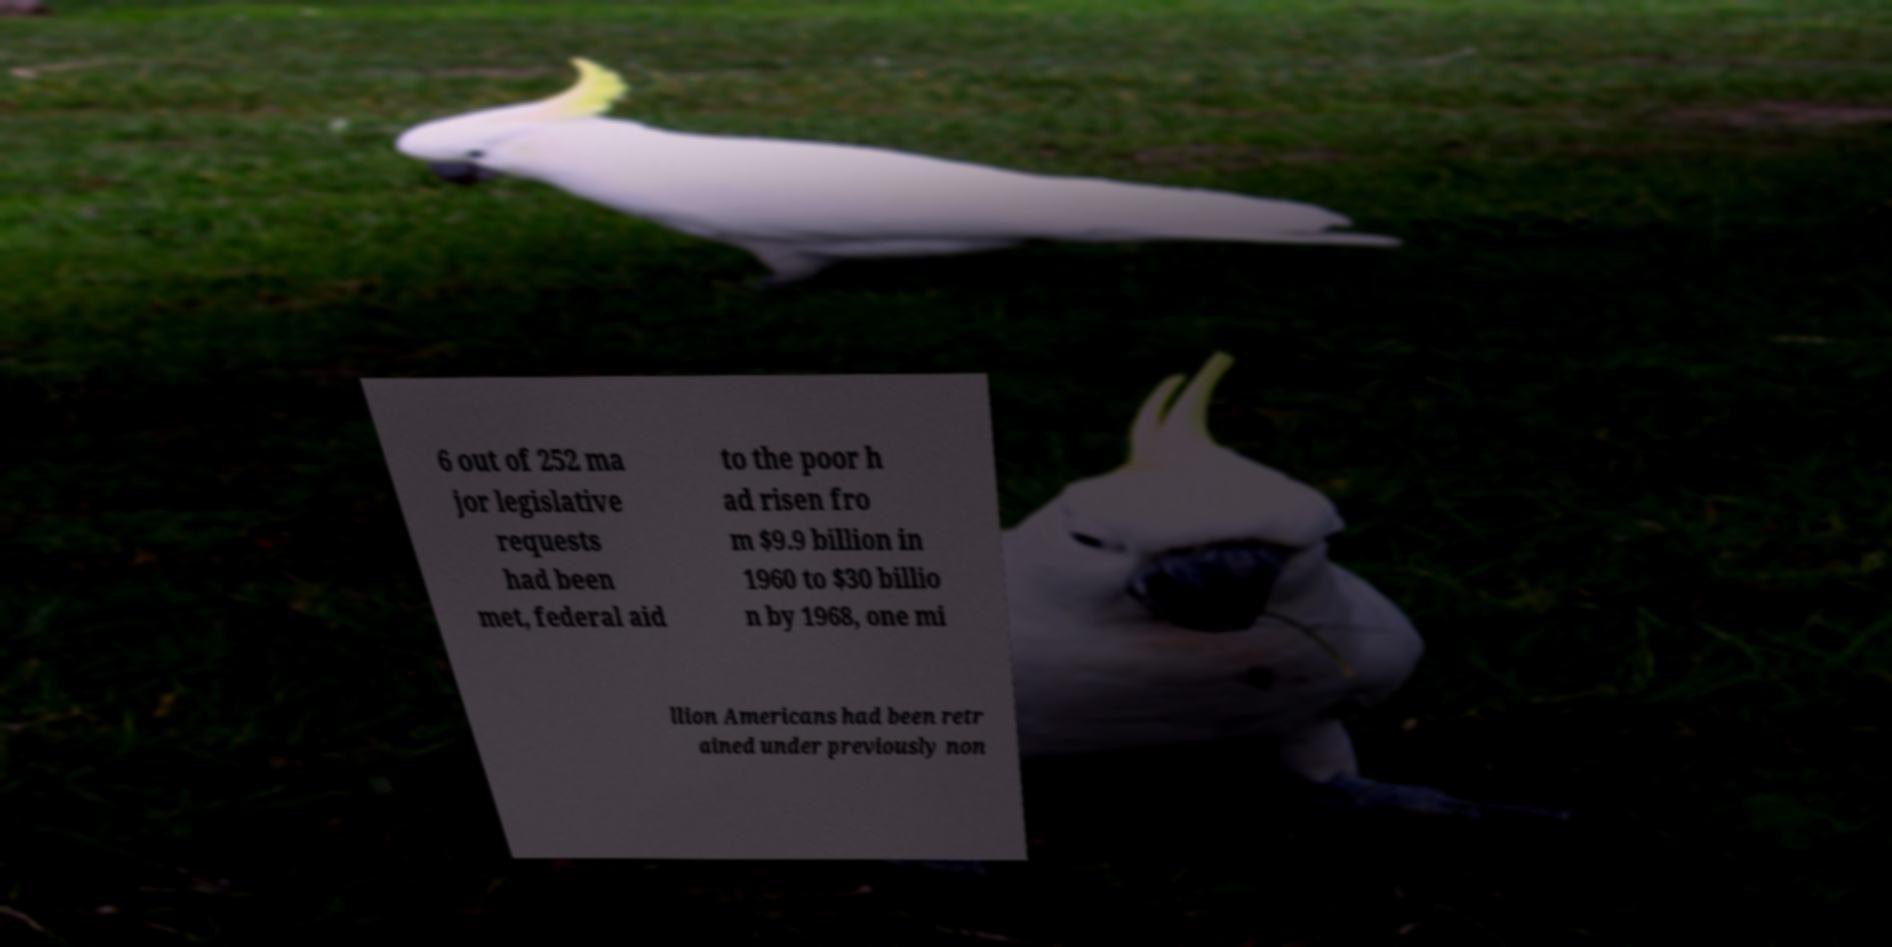For documentation purposes, I need the text within this image transcribed. Could you provide that? 6 out of 252 ma jor legislative requests had been met, federal aid to the poor h ad risen fro m $9.9 billion in 1960 to $30 billio n by 1968, one mi llion Americans had been retr ained under previously non 